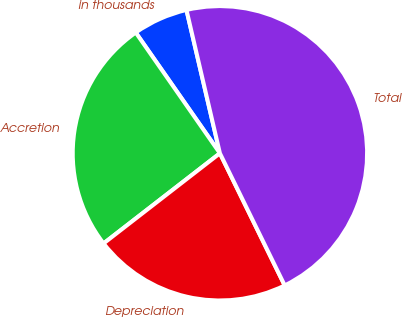Convert chart. <chart><loc_0><loc_0><loc_500><loc_500><pie_chart><fcel>in thousands<fcel>Accretion<fcel>Depreciation<fcel>Total<nl><fcel>6.04%<fcel>25.8%<fcel>21.76%<fcel>46.39%<nl></chart> 